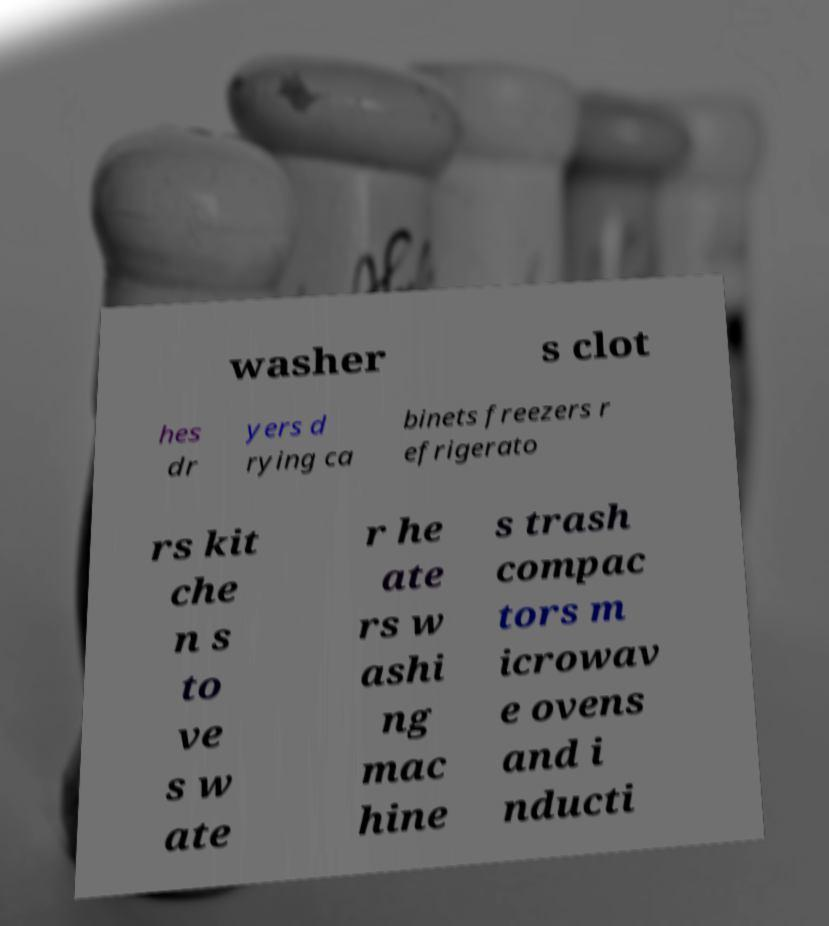I need the written content from this picture converted into text. Can you do that? washer s clot hes dr yers d rying ca binets freezers r efrigerato rs kit che n s to ve s w ate r he ate rs w ashi ng mac hine s trash compac tors m icrowav e ovens and i nducti 